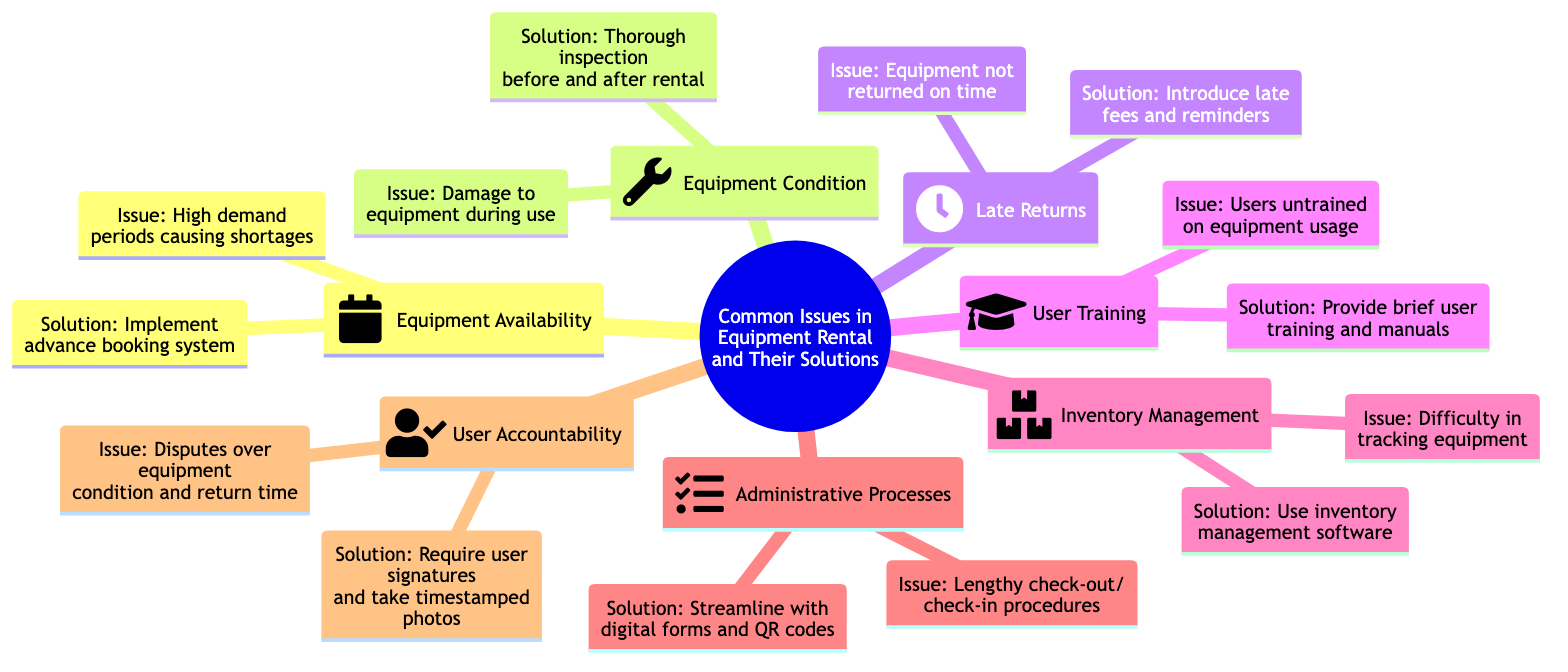What is the issue related to equipment availability? The diagram states that the issue related to equipment availability is "High demand periods causing shortages." This is directly listed under the Equipment Availability node.
Answer: High demand periods causing shortages What solution is provided for equipment condition issues? The solution provided for issues related to equipment condition is "Thorough inspection before and after rental." This is indicated under the Equipment Condition node.
Answer: Thorough inspection before and after rental How many main issues are identified in the diagram? The diagram lists seven main issues under the primary category of "Common Issues in Equipment Rental and Their Solutions." Counting those listed nodes gives us the answer.
Answer: Seven What is the solution for late returns? The solution for late returns is "Introduce late fees and reminders." This is specified under the Late Returns node in the diagram.
Answer: Introduce late fees and reminders Which node addresses user training? The node that addresses user training is labeled "User Training." It specifically discusses the issue of users being untrained on equipment usage.
Answer: User Training What might you implement to track equipment effectively? According to the diagram, one might implement "inventory management software" to track equipment effectively, as stated under the Inventory Management node.
Answer: Inventory management software What is introduced to remedy lengthy check-out/check-in procedures? The remedy introduced for lengthy check-out/check-in procedures is "Streamline with digital forms and QR codes." This solution is specified under the Administrative Processes node.
Answer: Streamline with digital forms and QR codes What solution addresses disputes over equipment condition? The solution addressing disputes over equipment condition and return time is "Require user signatures and take timestamped photos." This appears under the User Accountability node.
Answer: Require user signatures and take timestamped photos What type of diagram is this? This diagram is a "Mind Map," indicated by the structure that connects various issues and their corresponding solutions related to equipment rental.
Answer: Mind Map 